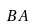<formula> <loc_0><loc_0><loc_500><loc_500>B A</formula> 